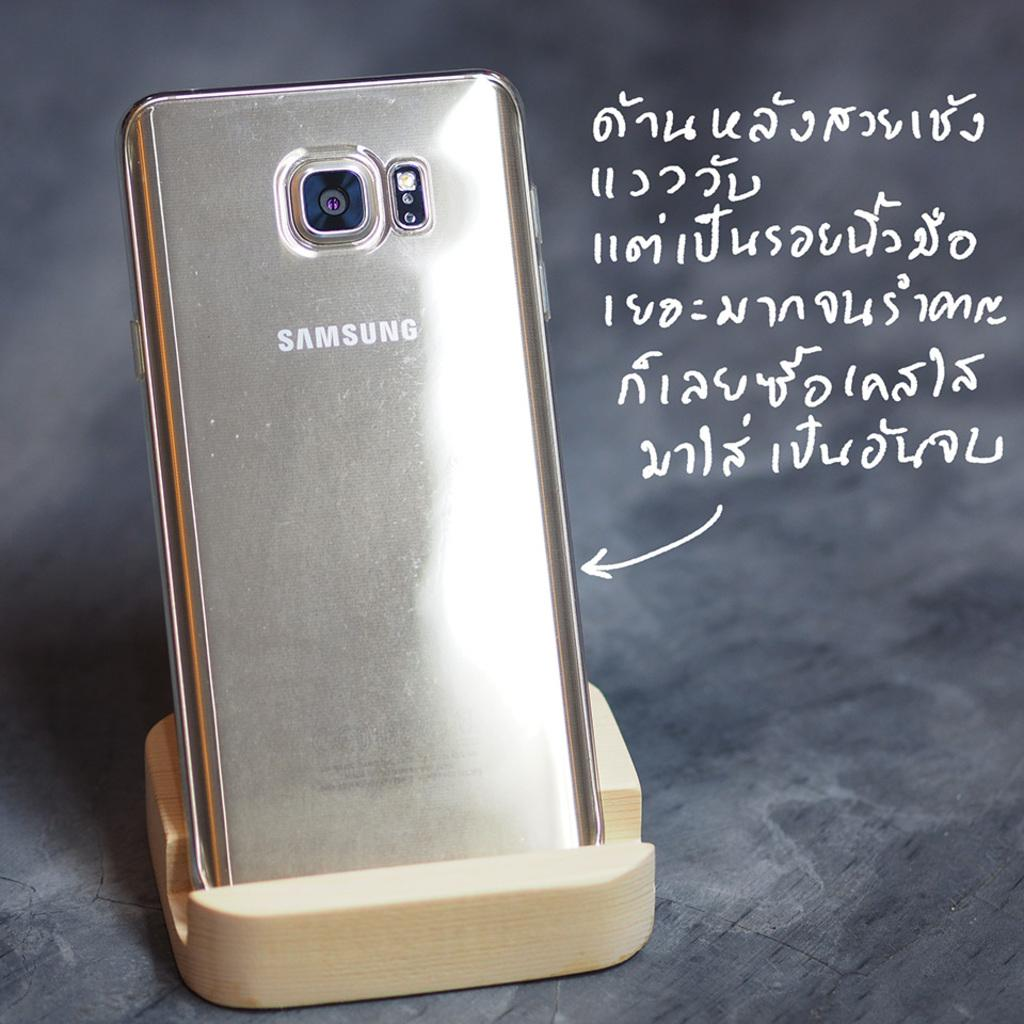<image>
Create a compact narrative representing the image presented. A gold samsung phone sitting on a charger with an arrow pointing to it. 